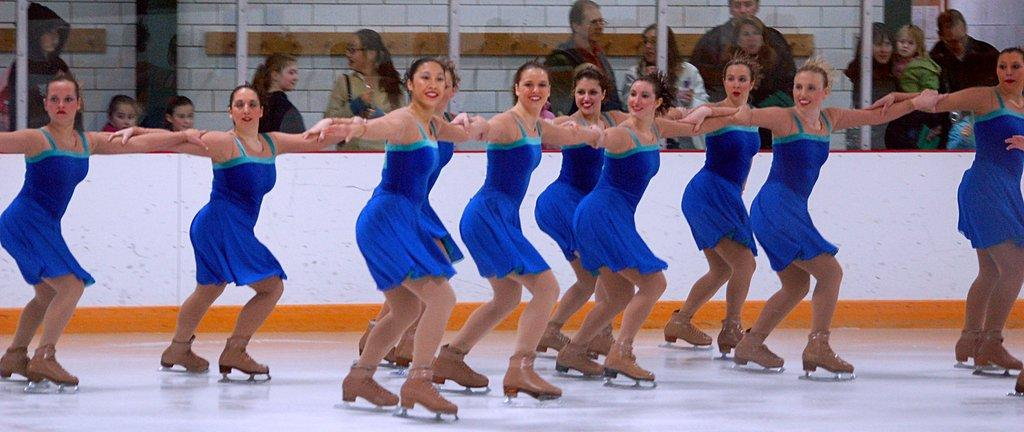Who is present in the image? There are ladies in the image. What are the ladies wearing? The ladies are wearing blue dresses. What activity are the ladies engaged in? The ladies are skating on ice. What can be seen in the background of the image? There are people in the background of the image. What type of cats can be seen playing with a belief in the image? There are no cats or beliefs present in the image; it features ladies ice skating with people in the background. Is there a horse visible in the image? No, there is no horse present in the image. 